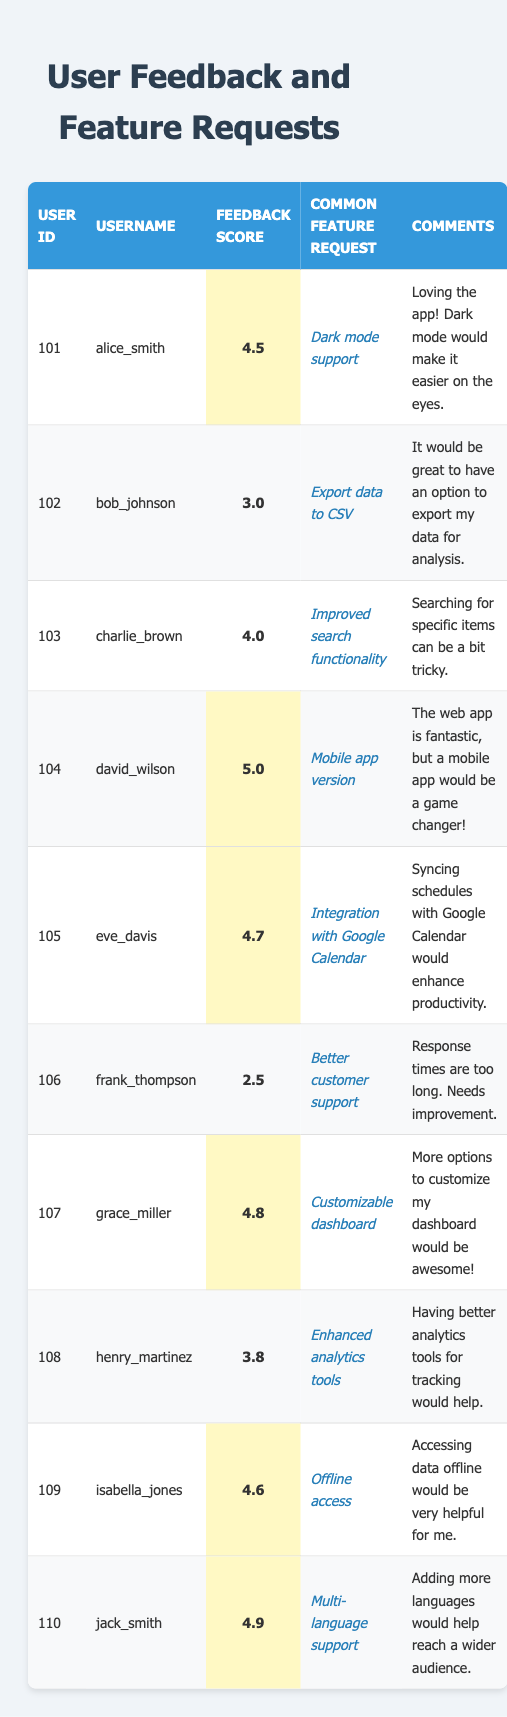What is the feedback score of grace_miller? To find grace_miller's feedback score, I locate the row corresponding to her username. The feedback score found in her row is 4.8.
Answer: 4.8 What is the common feature request from bob_johnson? By checking the row for bob_johnson, the common feature request listed is "Export data to CSV."
Answer: Export data to CSV Which user has the highest feedback score? I compare all the feedback scores in the table. The highest feedback score is 5.0, which belongs to david_wilson.
Answer: david_wilson What is the average feedback score of all users? To calculate the average, I need to sum all the feedback scores (4.5 + 3.0 + 4.0 + 5.0 + 4.7 + 2.5 + 4.8 + 3.8 + 4.6 + 4.9 = 43.8), then divide by the number of users (10). Therefore, the average is 43.8 / 10 = 4.38.
Answer: 4.38 Is there a user who requested "Offline access"? I can look through the table to find the corresponding feature request. Isabella_jones has requested "Offline access." Thus, the answer is yes.
Answer: Yes What feature request did the user with the lowest feedback score have? The user with the lowest feedback score is frank_thompson, who has a score of 2.5. His feature request is "Better customer support."
Answer: Better customer support How many users requested improvements related to functionality? I examine the feature requests for mentions of functionality improvements. Charlie_brown requested "Improved search functionality" and bob_johnson requested "Export data to CSV," indicating two users.
Answer: 2 What is the difference between the highest and lowest feedback scores? The highest score is 5.0 (david_wilson) and the lowest is 2.5 (frank_thompson). The difference is calculated as 5.0 - 2.5 = 2.5.
Answer: 2.5 Which feature requests are related to mobile or offline access? Looking through the feature requests, "Mobile app version" (david_wilson) and "Offline access" (isabella_jones) are related to mobile or offline access. Therefore, there are two such requests.
Answer: 2 How many users gave a feedback score of 4.5 or higher? I review the feedback scores to count those 4.5 or above: 4.5 (alice_smith), 5.0 (david_wilson), 4.7 (eve_davis), 4.8 (grace_miller), 4.6 (isabella_jones), and 4.9 (jack_smith). This gives us a total of six users.
Answer: 6 